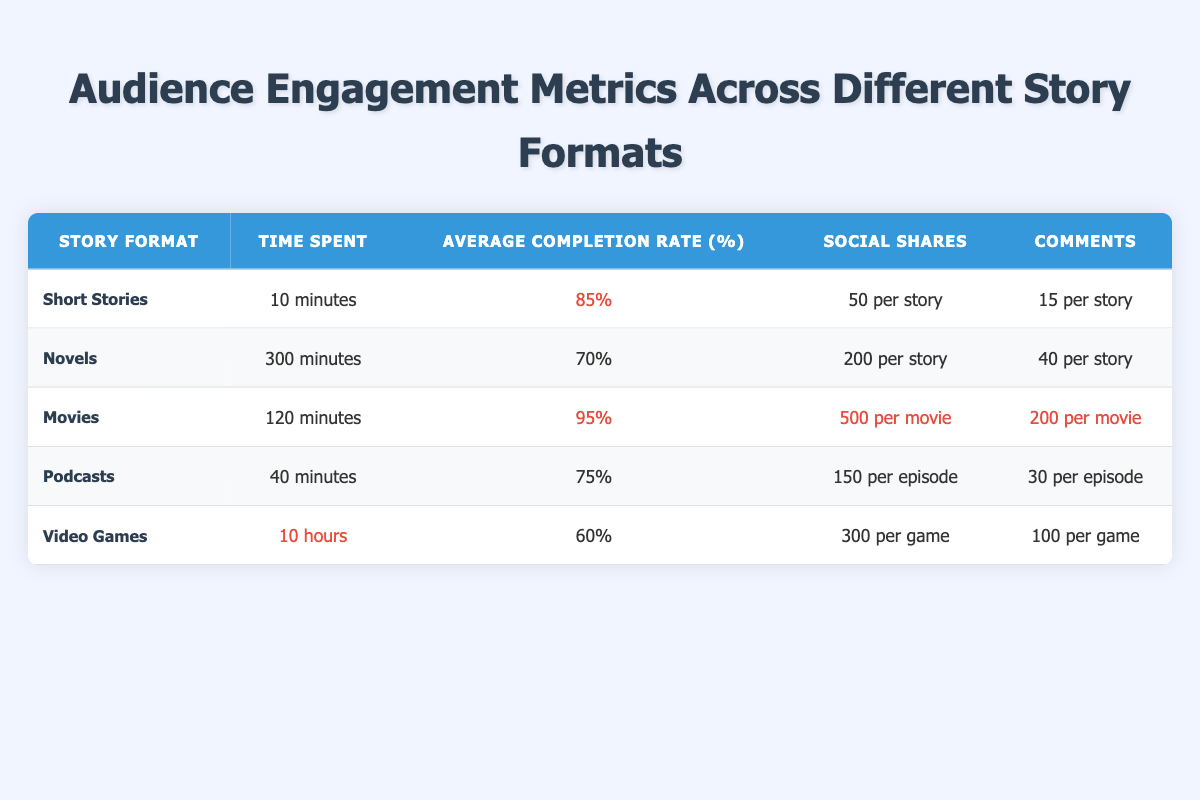What is the average completion rate for podcasts? The table indicates that the average completion rate for podcasts is 75%. This is a direct retrieval of the metric from the table.
Answer: 75% Which story format has the highest average completion rate? By examining the completion rates listed, Movies have the highest rate at 95%. This is determined by comparing all values in the Average Completion Rate column.
Answer: Movies How much time is spent on reading novels in total if someone reads three novels? As novels have a read time of 300 minutes each, reading three novels would total 300 * 3 = 900 minutes. This involves multiplication of the read time by the number of novels.
Answer: 900 minutes Are social shares for short stories greater than for podcasts? The table shows that short stories have 50 social shares per story, while podcasts have 150 social shares per episode. Since 50 is less than 150, the statement is false. This is a direct comparison of the values in the corresponding columns.
Answer: No What is the total time spent on video games if someone plays two games and each game takes 10 hours? Since each video game has a play time of 10 hours, playing two games would result in a total time of 10 * 2 = 20 hours. This calculation follows multiplication of the hours by the number of games played.
Answer: 20 hours Which story format has the highest number of comments per item? The movie format shows that it has 200 comments per movie, which is more than any other format listed (the next highest is 100 for video games). This is derived by identifying the maximum value in the Comments column.
Answer: Movies If someone listens to three podcast episodes, how many total social shares would that account for? Each podcast episode has 150 social shares, so for three episodes, the total would be 150 * 3 = 450 social shares. This arithmetic reflects multiplication of shares per episode by the number of episodes listened to.
Answer: 450 social shares Is the average completion rate for video games higher than 65%? The table indicates that video games have an average completion rate of 60%. Since 60% is not greater than 65%, the answer is no. This requires a comparison of the value with the threshold of 65%.
Answer: No 